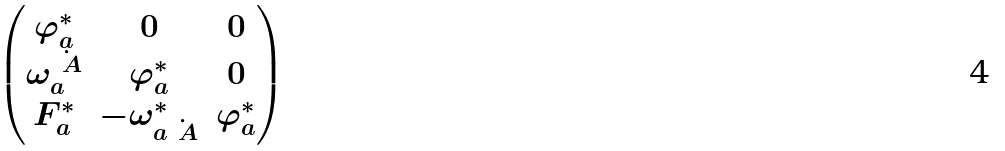<formula> <loc_0><loc_0><loc_500><loc_500>\begin{pmatrix} \varphi _ { a } ^ { * } & 0 & 0 \\ \omega _ { a } ^ { \dot { \ A } } & \varphi _ { a } ^ { * } & 0 \\ F _ { a } ^ { * } & - \omega ^ { * } _ { a \dot { \ A } } & \varphi _ { a } ^ { * } \end{pmatrix}</formula> 